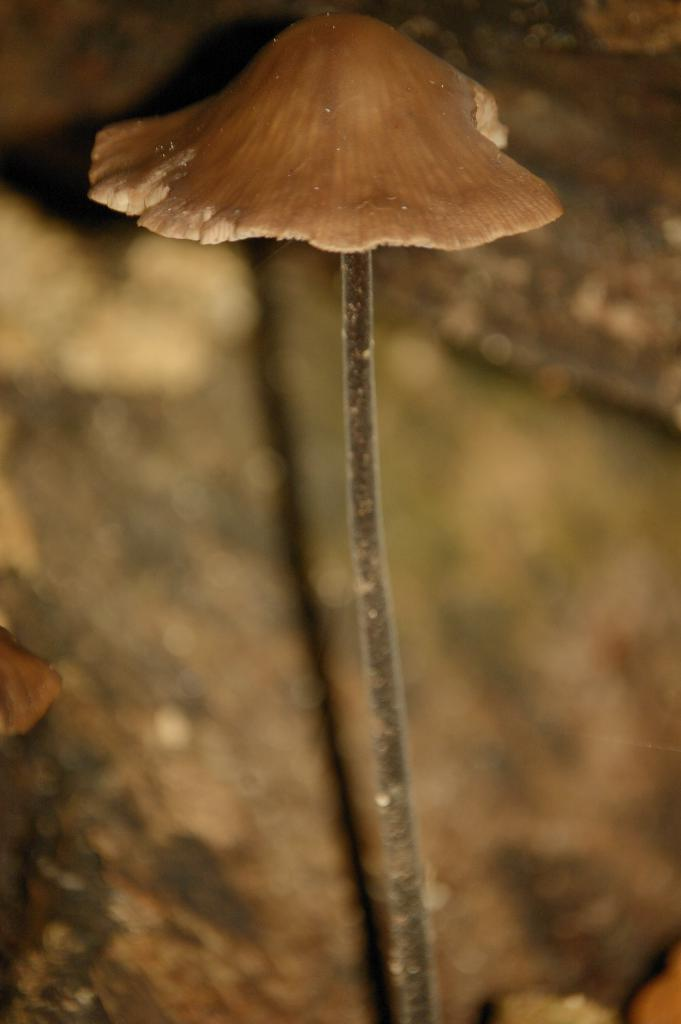What is the main subject of the image? There is a mushroom in the image. What part of the mushroom is visible in the image? There is a stem in the image. Can you describe the background of the image? The background of the image is blurry. What hobbies does the mushroom enjoy in the image? Mushrooms do not have hobbies, as they are inanimate objects. 